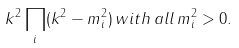Convert formula to latex. <formula><loc_0><loc_0><loc_500><loc_500>k ^ { 2 } \prod _ { i } ( { k } ^ { 2 } - { m } _ { i } ^ { 2 } ) \, w i t h \, a l l \, { m } _ { i } ^ { 2 } > 0 .</formula> 